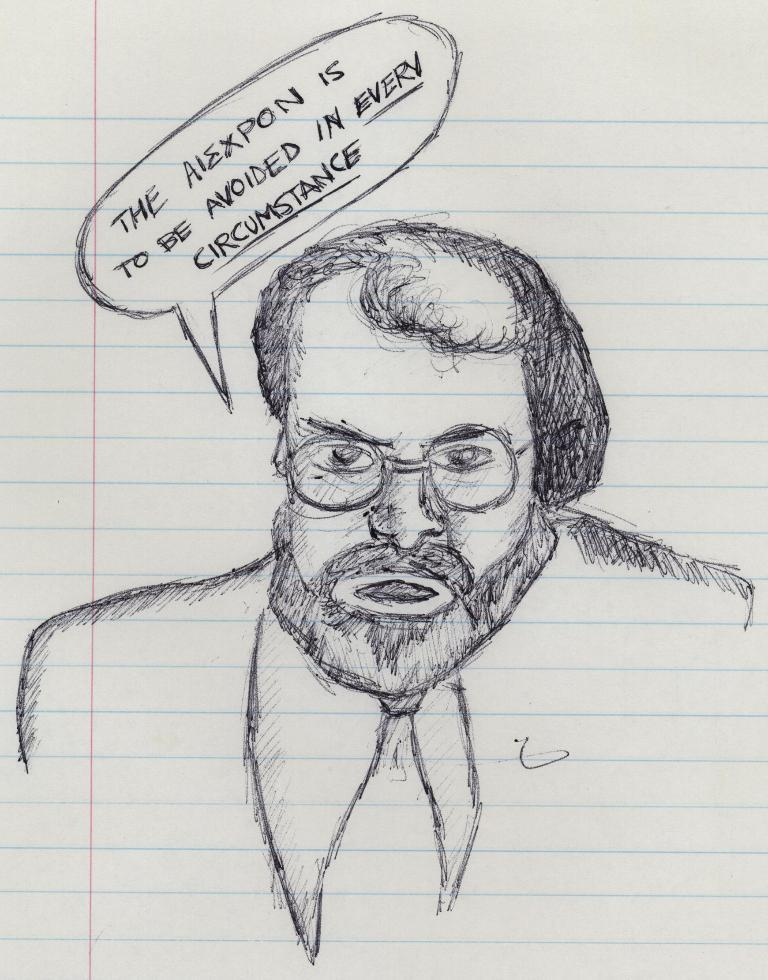What is depicted on the paper in the image? There is a drawing of a person on a paper in the image. What else can be seen at the top of the image? There is text written at the top of the image. What type of arch can be seen in the background of the image? There is no arch present in the image; it only features a drawing of a person on a paper and text at the top. 